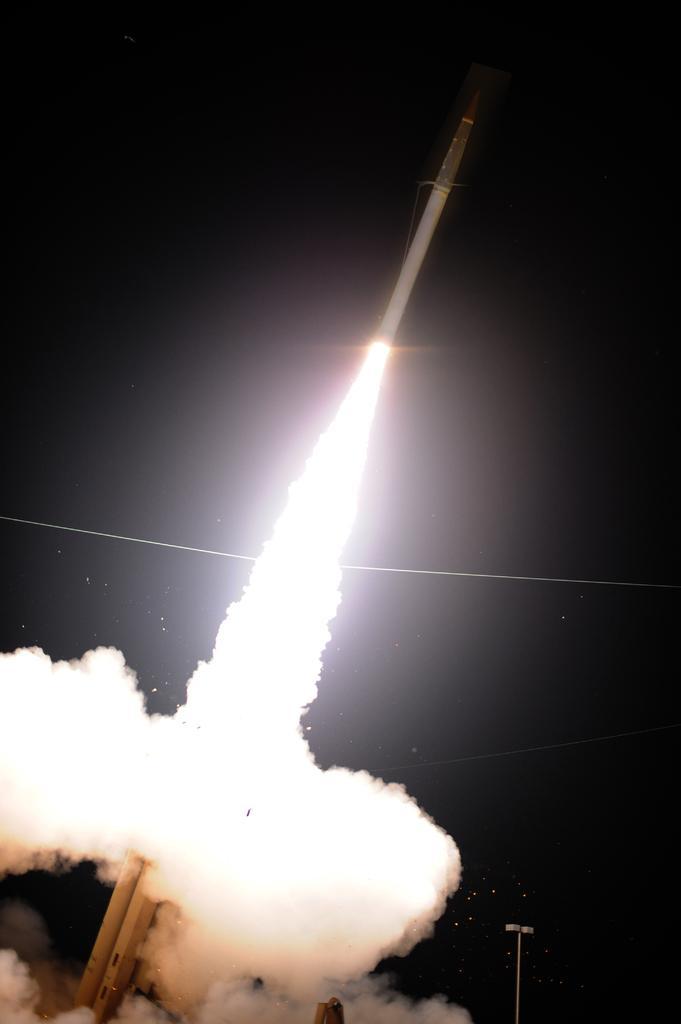Can you describe this image briefly? In the picture I can see a rocket is flying in the air. Here we can see the white color smoke, light poles and the dark sky in the background. 